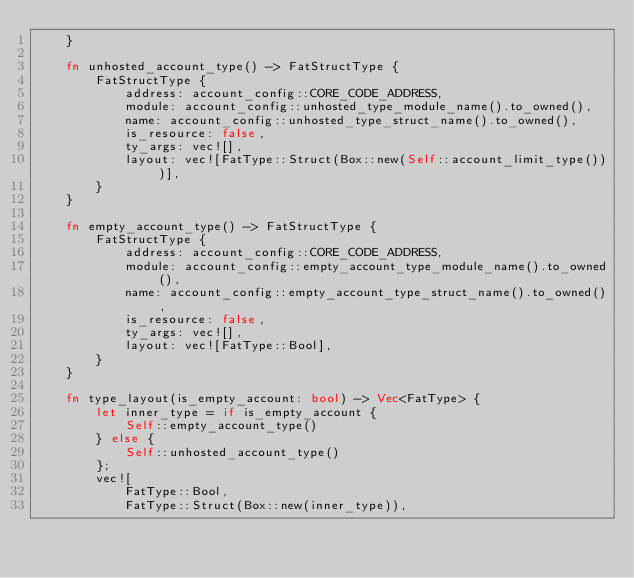Convert code to text. <code><loc_0><loc_0><loc_500><loc_500><_Rust_>    }

    fn unhosted_account_type() -> FatStructType {
        FatStructType {
            address: account_config::CORE_CODE_ADDRESS,
            module: account_config::unhosted_type_module_name().to_owned(),
            name: account_config::unhosted_type_struct_name().to_owned(),
            is_resource: false,
            ty_args: vec![],
            layout: vec![FatType::Struct(Box::new(Self::account_limit_type()))],
        }
    }

    fn empty_account_type() -> FatStructType {
        FatStructType {
            address: account_config::CORE_CODE_ADDRESS,
            module: account_config::empty_account_type_module_name().to_owned(),
            name: account_config::empty_account_type_struct_name().to_owned(),
            is_resource: false,
            ty_args: vec![],
            layout: vec![FatType::Bool],
        }
    }

    fn type_layout(is_empty_account: bool) -> Vec<FatType> {
        let inner_type = if is_empty_account {
            Self::empty_account_type()
        } else {
            Self::unhosted_account_type()
        };
        vec![
            FatType::Bool,
            FatType::Struct(Box::new(inner_type)),</code> 